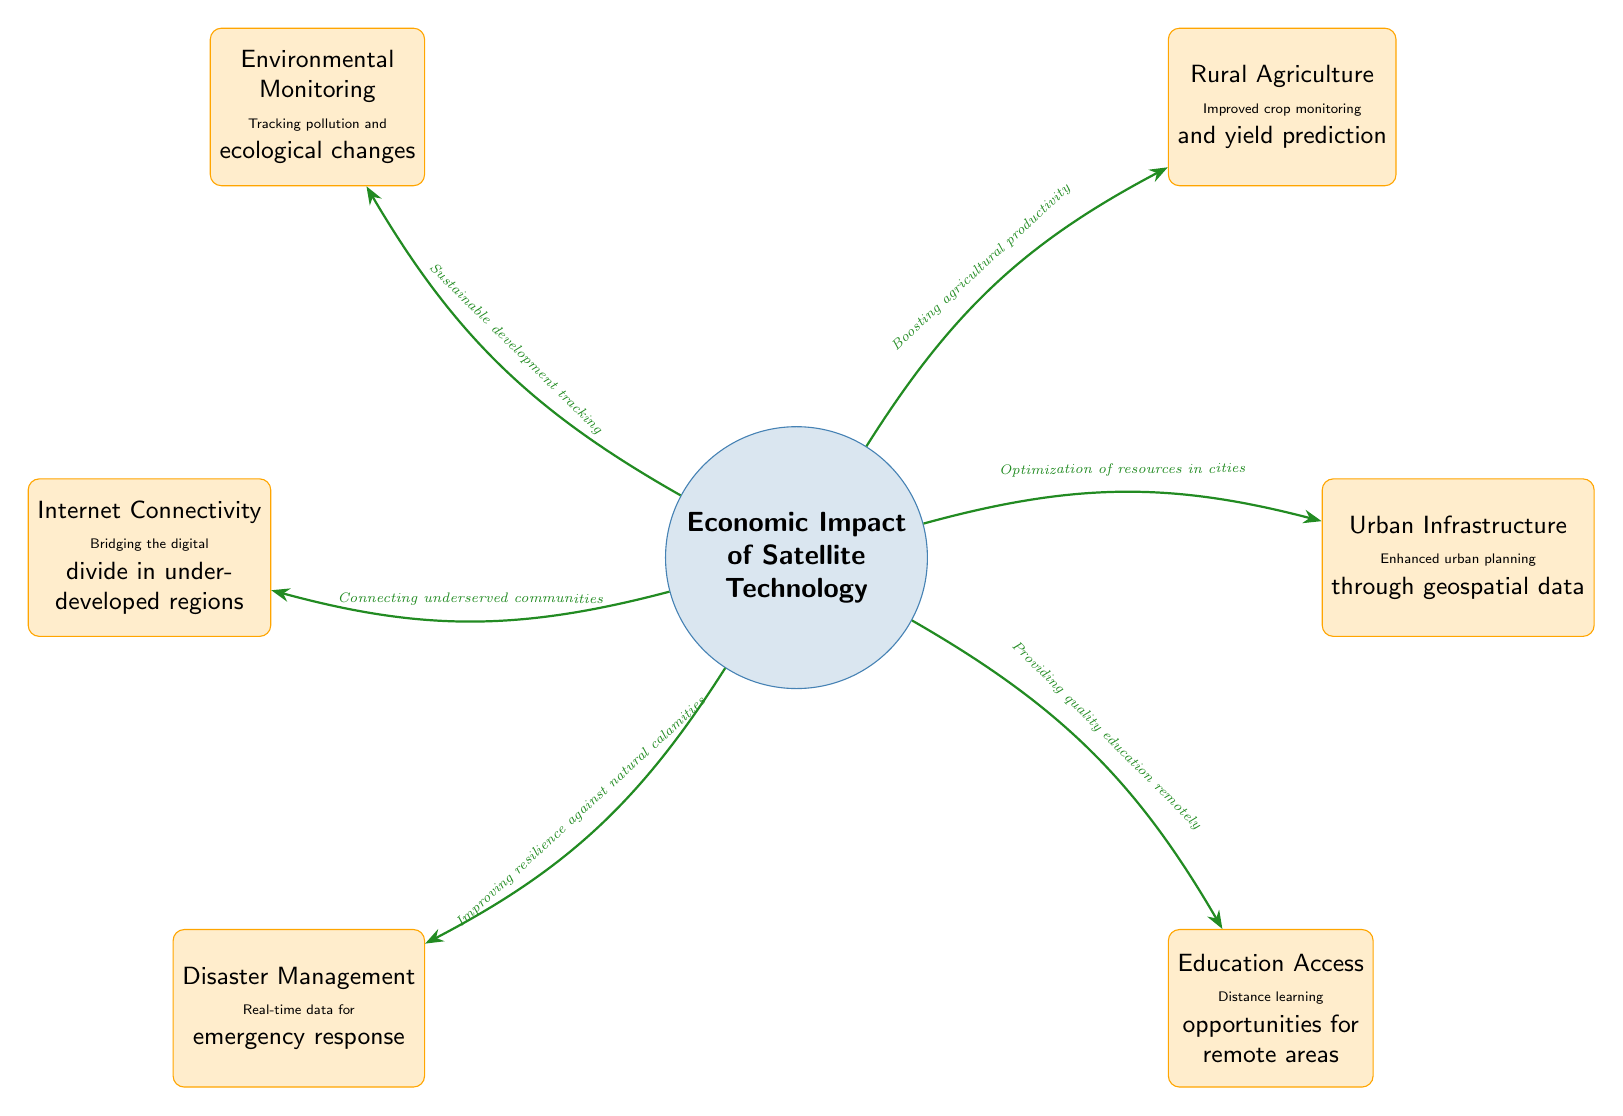What is the central focus of the diagram? The diagram focuses on the "Economic Impact of Satellite Technology". This can be identified by looking at the central node labeled clearly at the middle of the diagram.
Answer: Economic Impact of Satellite Technology How many satellite nodes are present in the diagram? By counting the nodes connected to the central node, we see there are six satellite nodes surrounding it, each representing different areas of impact.
Answer: 6 What does the connection to "Rural Agriculture" indicate? The connection line from the central node to "Rural Agriculture" suggests that satellite technology boosts agricultural productivity, as described in the label on the arrow connecting them.
Answer: Boosting agricultural productivity Which node is directly linked to "Disaster Management"? The node "Disaster Management" is directly linked to the central node. This can be observed by tracing the connection line from the central node to that specific satellite node.
Answer: Disaster Management What role does satellite technology play in urban infrastructure? The diagram states that satellite technology leads to the "Optimization of resources in cities," indicating its role in enhancing urban planning. This is specifically outlined in the connection from the central node to "Urban Infrastructure".
Answer: Optimization of resources in cities How does satellite technology contribute to education? The diagram illustrates that satellite technology provides "Distance learning opportunities for remote areas", signifying its impact on increasing access to education in those locations.
Answer: Providing quality education remotely Which satellite node focuses on environmental issues? The node labeled "Environmental Monitoring" specifically addresses environmental issues, which can be recognized by its positioning and the accompanying description detailing its roles.
Answer: Environmental Monitoring What is the connection between the "Internet Connectivity" node and the central theme? The connection to "Internet Connectivity" underscores the role of satellite technology in "Connecting underserved communities," which is articulated in the description along the connecting line.
Answer: Connecting underserved communities What would be the impact of satellite technology on disaster management according to the diagram? The diagram states that satellite technology improves resilience against natural calamities, which aligns with the description provided on the connection to "Disaster Management".
Answer: Improving resilience against natural calamities What type of educational opportunities does satellite technology enhance? According to the diagram, satellite technology enhances distance learning opportunities, making education more accessible to remote areas, as indicated in the description associated with the "Education Access" node.
Answer: Distance learning opportunities for remote areas 